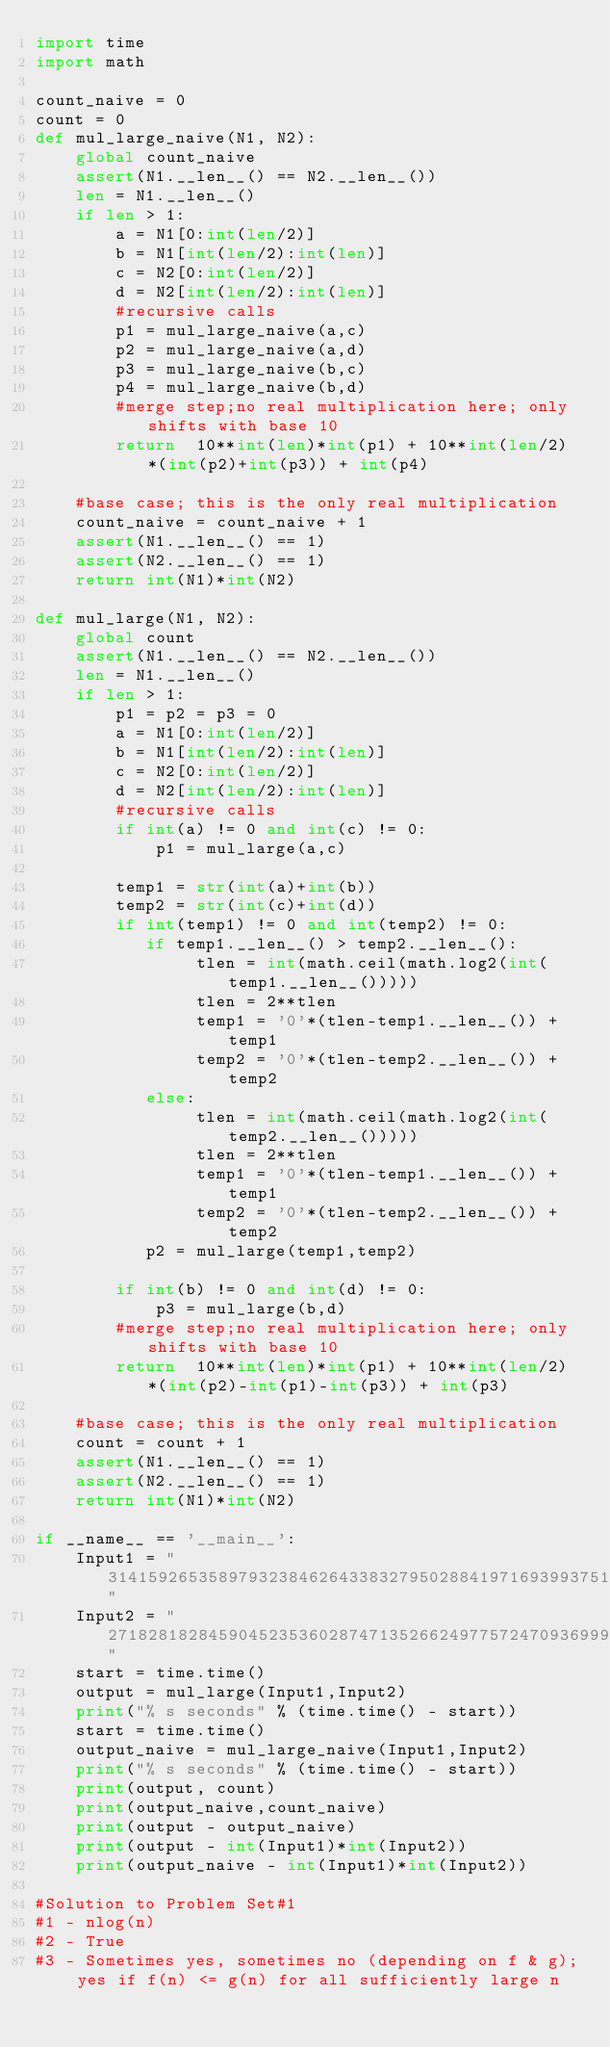<code> <loc_0><loc_0><loc_500><loc_500><_Python_>import time
import math

count_naive = 0
count = 0
def mul_large_naive(N1, N2):
    global count_naive
    assert(N1.__len__() == N2.__len__())
    len = N1.__len__()
    if len > 1:
        a = N1[0:int(len/2)]
        b = N1[int(len/2):int(len)]
        c = N2[0:int(len/2)]
        d = N2[int(len/2):int(len)]
		#recursive calls
        p1 = mul_large_naive(a,c)
        p2 = mul_large_naive(a,d)
        p3 = mul_large_naive(b,c)
        p4 = mul_large_naive(b,d)
		#merge step;no real multiplication here; only shifts with base 10
        return  10**int(len)*int(p1) + 10**int(len/2)*(int(p2)+int(p3)) + int(p4)
		
    #base case; this is the only real multiplication
    count_naive = count_naive + 1
    assert(N1.__len__() == 1)
    assert(N2.__len__() == 1)
    return int(N1)*int(N2)

def mul_large(N1, N2):
    global count
    assert(N1.__len__() == N2.__len__())
    len = N1.__len__()
    if len > 1:
        p1 = p2 = p3 = 0
        a = N1[0:int(len/2)]
        b = N1[int(len/2):int(len)]
        c = N2[0:int(len/2)]
        d = N2[int(len/2):int(len)]
		#recursive calls
        if int(a) != 0 and int(c) != 0:
            p1 = mul_large(a,c)

        temp1 = str(int(a)+int(b))
        temp2 = str(int(c)+int(d))
        if int(temp1) != 0 and int(temp2) != 0:
           if temp1.__len__() > temp2.__len__():
                tlen = int(math.ceil(math.log2(int(temp1.__len__()))))
                tlen = 2**tlen
                temp1 = '0'*(tlen-temp1.__len__()) + temp1
                temp2 = '0'*(tlen-temp2.__len__()) + temp2
           else:
                tlen = int(math.ceil(math.log2(int(temp2.__len__()))))
                tlen = 2**tlen
                temp1 = '0'*(tlen-temp1.__len__()) + temp1
                temp2 = '0'*(tlen-temp2.__len__()) + temp2
           p2 = mul_large(temp1,temp2)

        if int(b) != 0 and int(d) != 0:
            p3 = mul_large(b,d)
		#merge step;no real multiplication here; only shifts with base 10
        return  10**int(len)*int(p1) + 10**int(len/2)*(int(p2)-int(p1)-int(p3)) + int(p3)
		
    #base case; this is the only real multiplication
    count = count + 1
    assert(N1.__len__() == 1)
    assert(N2.__len__() == 1)
    return int(N1)*int(N2)
		
if __name__ == '__main__':
    Input1 = "3141592653589793238462643383279502884197169399375105820974944592"
    Input2 = "2718281828459045235360287471352662497757247093699959574966967627"
    start = time.time()
    output = mul_large(Input1,Input2)
    print("% s seconds" % (time.time() - start))
    start = time.time()
    output_naive = mul_large_naive(Input1,Input2)
    print("% s seconds" % (time.time() - start))    
    print(output, count)
    print(output_naive,count_naive)
    print(output - output_naive)
    print(output - int(Input1)*int(Input2))
    print(output_naive - int(Input1)*int(Input2))
	
#Solution to Problem Set#1
#1 - nlog(n)
#2 - True
#3 - Sometimes yes, sometimes no (depending on f & g); yes if f(n) <= g(n) for all sufficiently large n</code> 